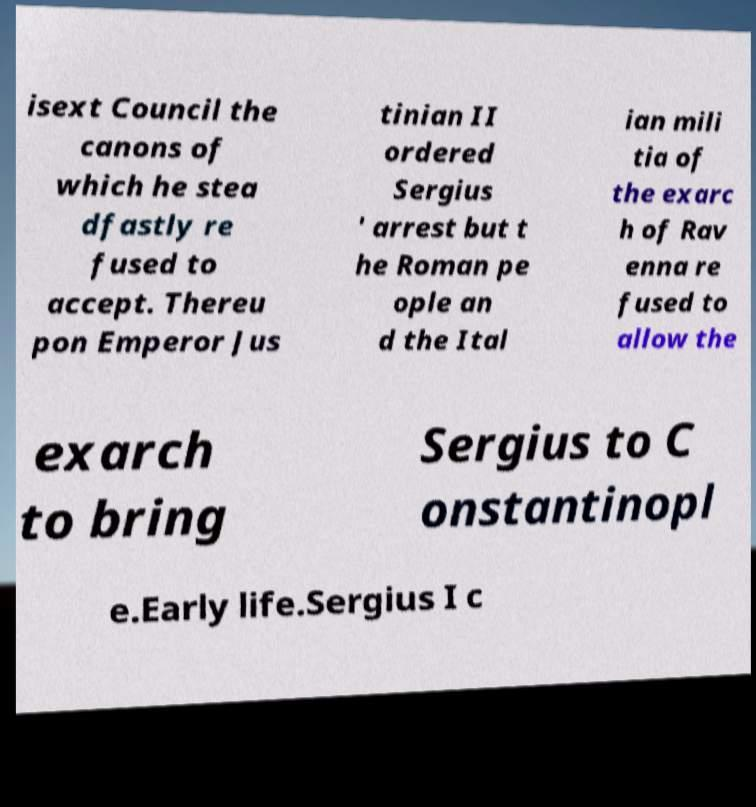Please read and relay the text visible in this image. What does it say? isext Council the canons of which he stea dfastly re fused to accept. Thereu pon Emperor Jus tinian II ordered Sergius ' arrest but t he Roman pe ople an d the Ital ian mili tia of the exarc h of Rav enna re fused to allow the exarch to bring Sergius to C onstantinopl e.Early life.Sergius I c 